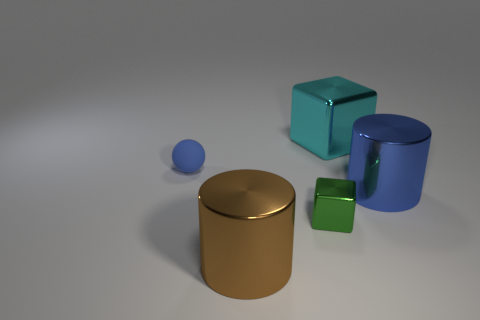Add 4 big cyan metal things. How many objects exist? 9 Subtract 1 cylinders. How many cylinders are left? 1 Subtract all balls. How many objects are left? 4 Add 2 small green metallic objects. How many small green metallic objects are left? 3 Add 3 big brown shiny things. How many big brown shiny things exist? 4 Subtract 0 blue cubes. How many objects are left? 5 Subtract all red blocks. Subtract all cyan spheres. How many blocks are left? 2 Subtract all red cylinders. How many green cubes are left? 1 Subtract all cyan metal objects. Subtract all large cylinders. How many objects are left? 2 